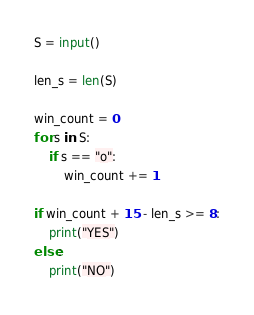Convert code to text. <code><loc_0><loc_0><loc_500><loc_500><_Python_>S = input()

len_s = len(S)

win_count = 0
for s in S:
    if s == "o":
        win_count += 1

if win_count + 15 - len_s >= 8:
    print("YES")
else:
    print("NO")
</code> 